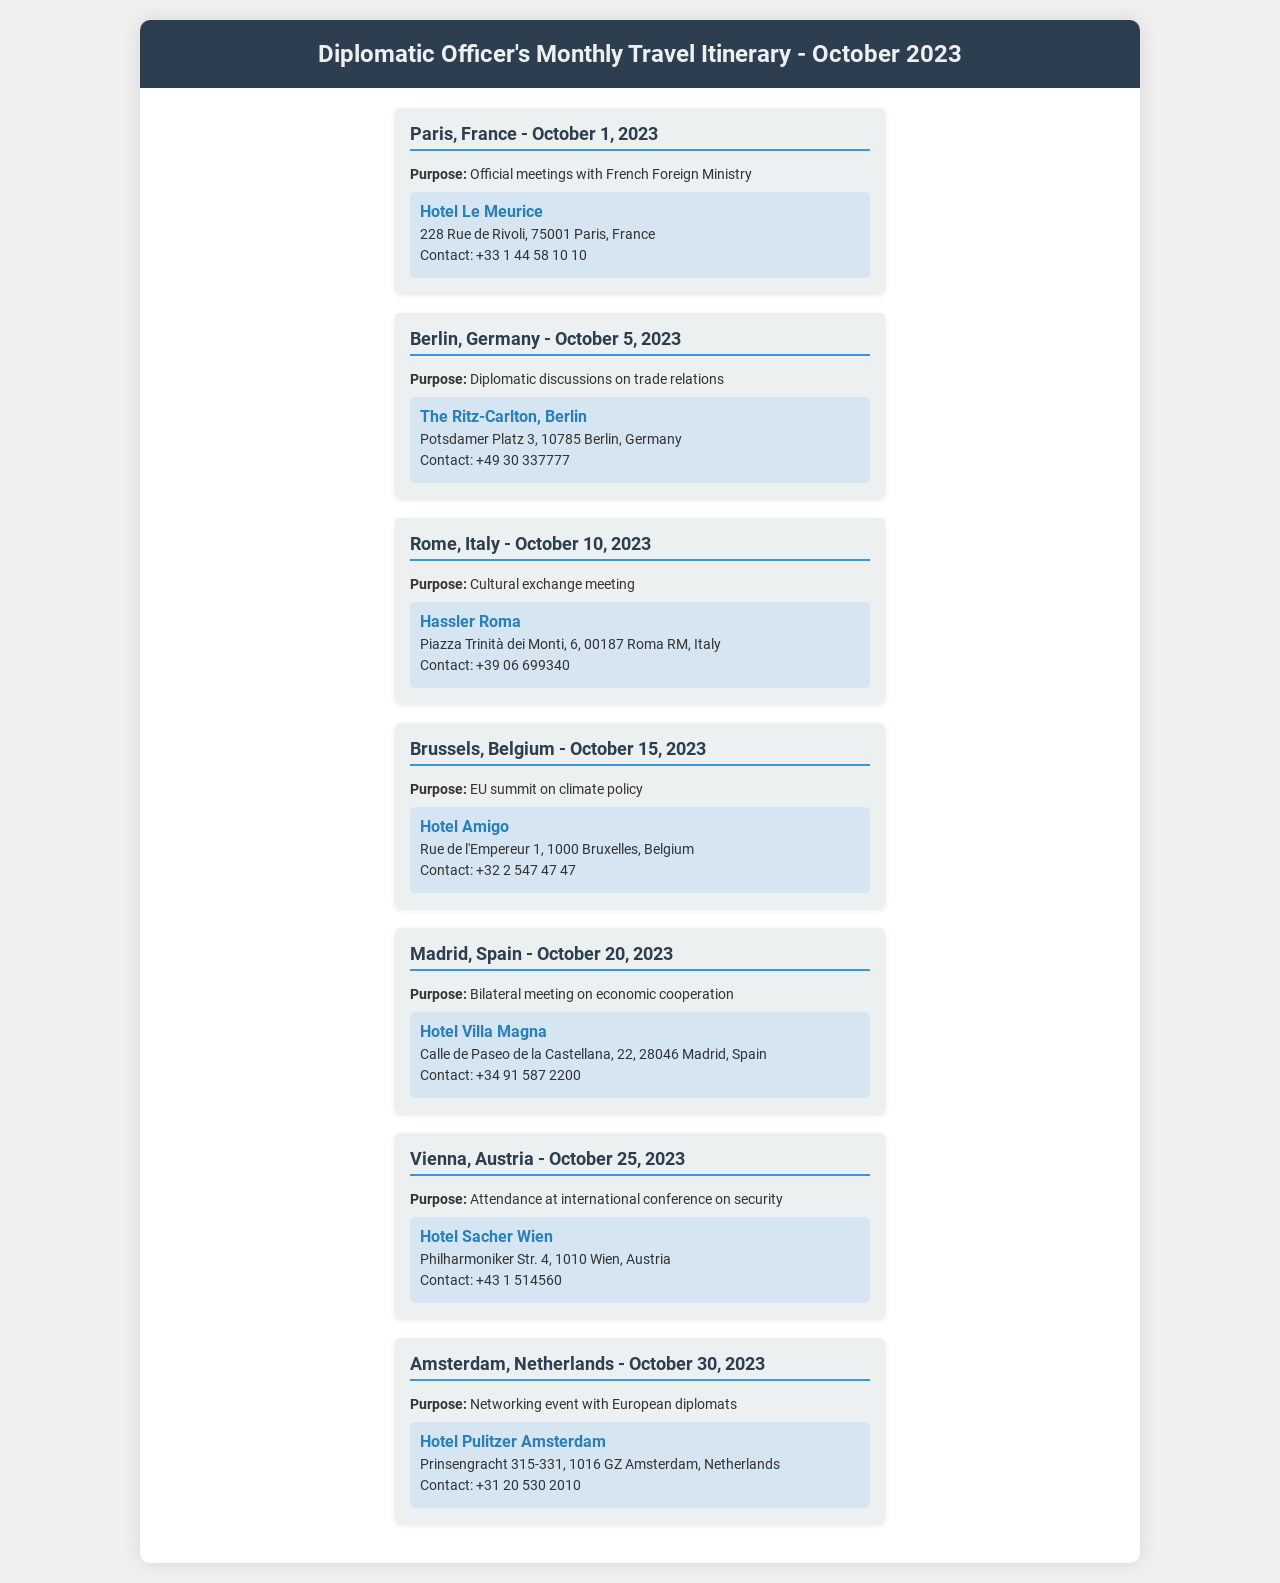What is the first destination on the itinerary? The first destination listed in the itinerary is Paris, France.
Answer: Paris, France What is the purpose of the visit to Berlin? The purpose of the visit to Berlin is diplomatic discussions on trade relations.
Answer: Diplomatic discussions on trade relations When will the diplomatic officer visit Madrid? The document states that the visit to Madrid is scheduled for October 20, 2023.
Answer: October 20, 2023 Which hotel is the accommodation in Vienna? The accommodation in Vienna is at Hotel Sacher Wien.
Answer: Hotel Sacher Wien How many trips are planned in total? The document lists a total of six trips planned for the month.
Answer: Six What is the contact number for the accommodation in Brussels? The contact number for Hotel Amigo in Brussels is provided as +32 2 547 47 47.
Answer: +32 2 547 47 47 What type of meeting is scheduled in Rome? The meeting scheduled in Rome is a cultural exchange meeting.
Answer: Cultural exchange meeting Which city is associated with an international conference on security? The document states that the international conference on security is in Vienna.
Answer: Vienna What is the last destination on the itinerary? The last destination mentioned in the itinerary is Amsterdam, Netherlands.
Answer: Amsterdam, Netherlands 